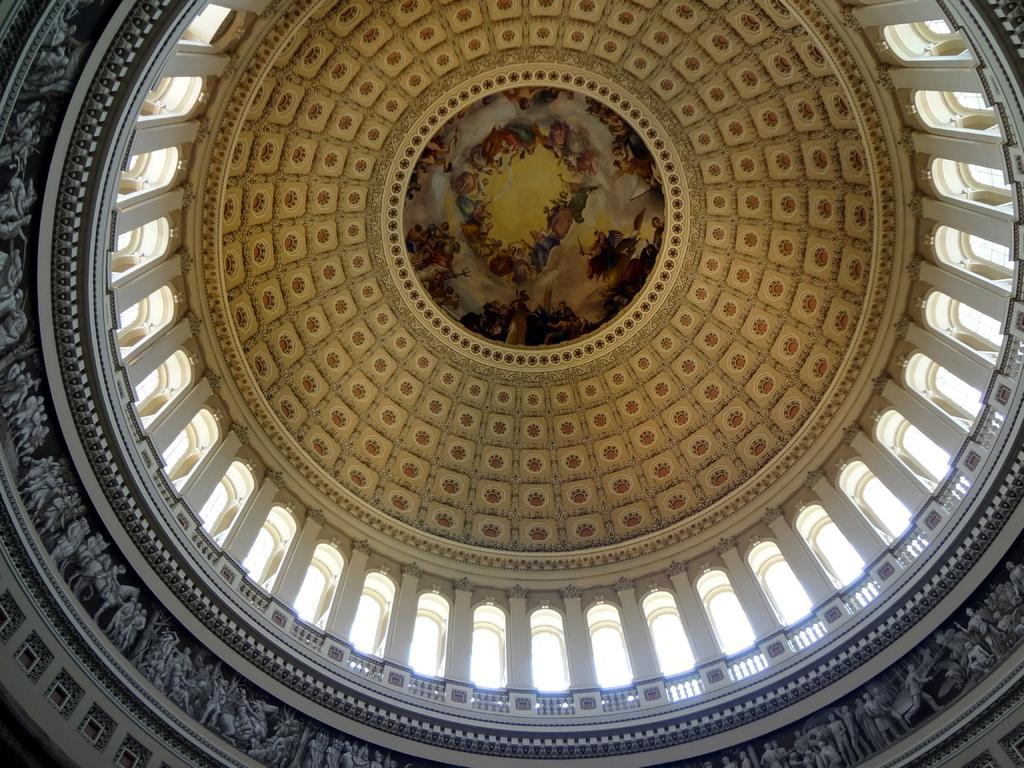In one or two sentences, can you explain what this image depicts? In this image we can see the inner view of a building which looks like a dome and we can see some sculptures on the wall. We can see the ceiling with painting. 